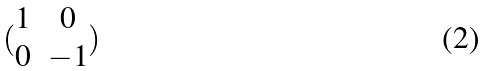Convert formula to latex. <formula><loc_0><loc_0><loc_500><loc_500>( \begin{matrix} 1 & 0 \\ 0 & - 1 \end{matrix} )</formula> 